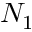<formula> <loc_0><loc_0><loc_500><loc_500>N _ { 1 }</formula> 